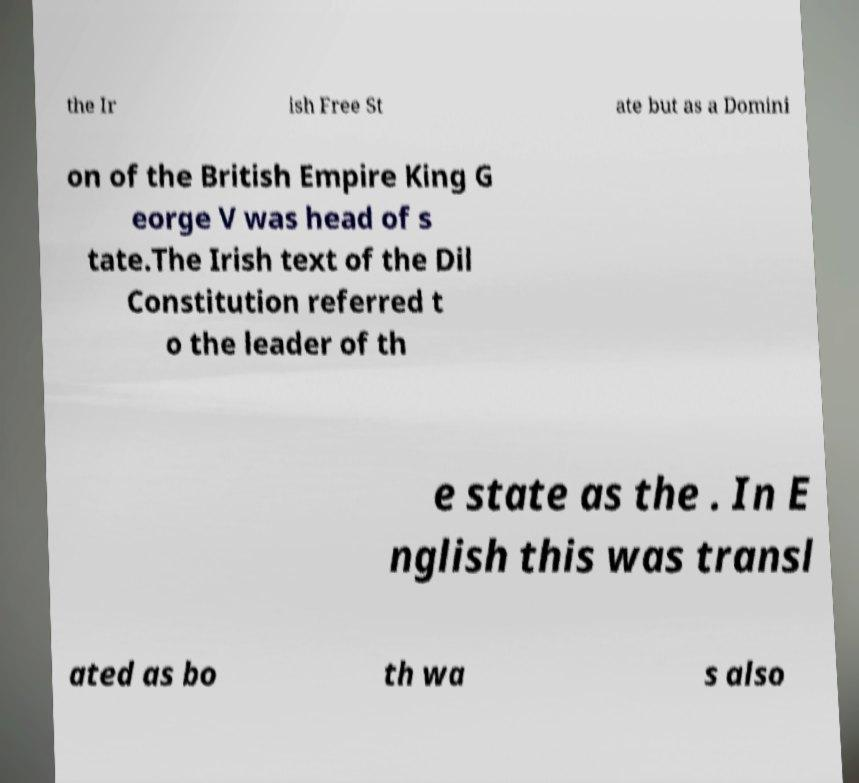For documentation purposes, I need the text within this image transcribed. Could you provide that? the Ir ish Free St ate but as a Domini on of the British Empire King G eorge V was head of s tate.The Irish text of the Dil Constitution referred t o the leader of th e state as the . In E nglish this was transl ated as bo th wa s also 